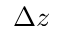Convert formula to latex. <formula><loc_0><loc_0><loc_500><loc_500>\Delta z</formula> 